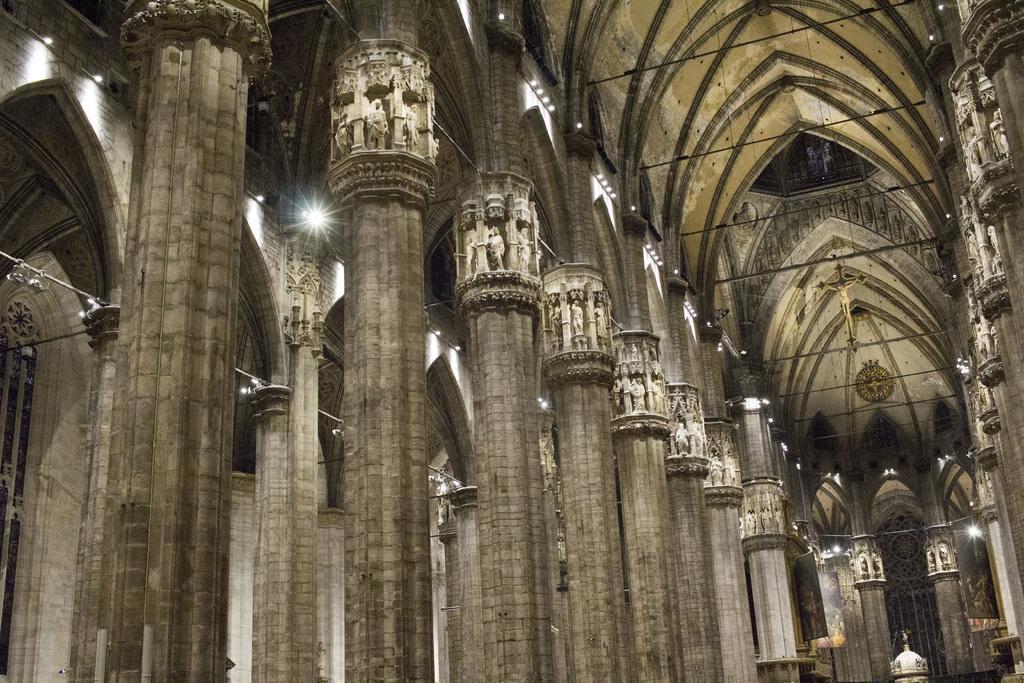Can you describe this image briefly? This is the inside picture of a church. In this image we can see pillars on both right and left side and we can also see lights inside the church. 